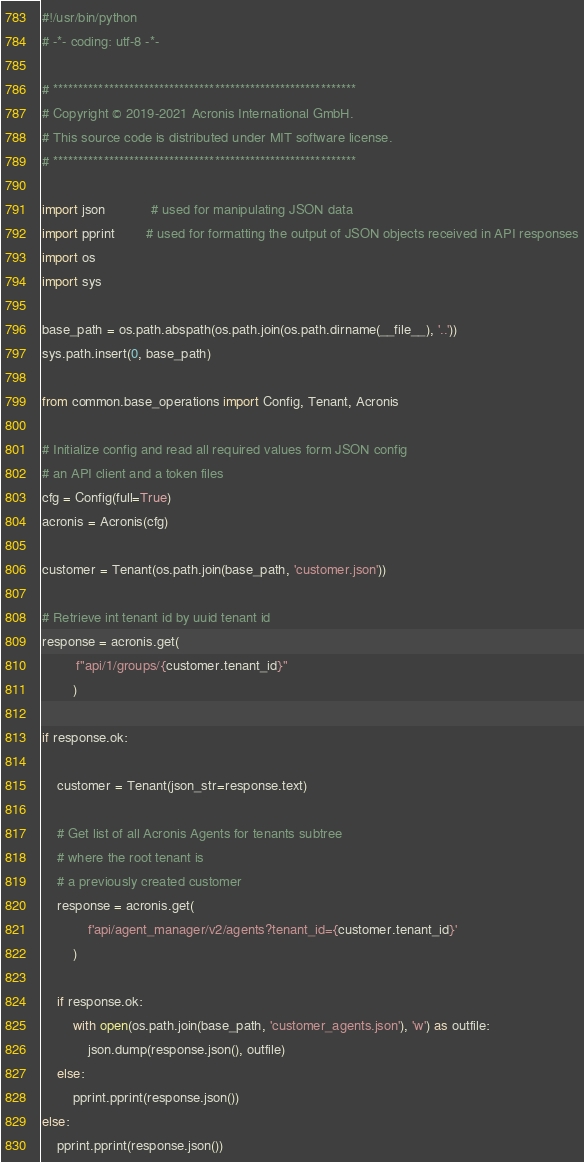Convert code to text. <code><loc_0><loc_0><loc_500><loc_500><_Python_>#!/usr/bin/python
# -*- coding: utf-8 -*-

# ************************************************************
# Copyright © 2019-2021 Acronis International GmbH.
# This source code is distributed under MIT software license.
# ************************************************************

import json			# used for manipulating JSON data
import pprint		# used for formatting the output of JSON objects received in API responses
import os
import sys

base_path = os.path.abspath(os.path.join(os.path.dirname(__file__), '..'))
sys.path.insert(0, base_path)

from common.base_operations import Config, Tenant, Acronis

# Initialize config and read all required values form JSON config
# an API client and a token files
cfg = Config(full=True)
acronis = Acronis(cfg)

customer = Tenant(os.path.join(base_path, 'customer.json'))

# Retrieve int tenant id by uuid tenant id
response = acronis.get(
         f"api/1/groups/{customer.tenant_id}"
        )

if response.ok:

    customer = Tenant(json_str=response.text)

    # Get list of all Acronis Agents for tenants subtree
    # where the root tenant is
    # a previously created customer
    response = acronis.get(
            f'api/agent_manager/v2/agents?tenant_id={customer.tenant_id}'
        )

    if response.ok:
        with open(os.path.join(base_path, 'customer_agents.json'), 'w') as outfile:
            json.dump(response.json(), outfile)
    else:
        pprint.pprint(response.json())
else:
    pprint.pprint(response.json())
</code> 